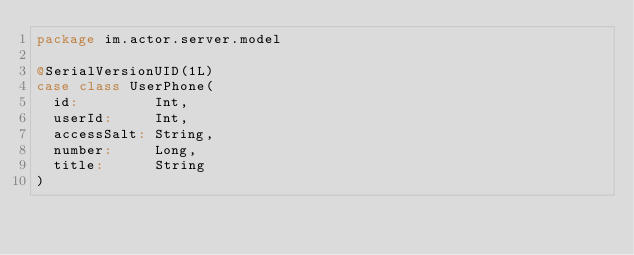Convert code to text. <code><loc_0><loc_0><loc_500><loc_500><_Scala_>package im.actor.server.model

@SerialVersionUID(1L)
case class UserPhone(
  id:         Int,
  userId:     Int,
  accessSalt: String,
  number:     Long,
  title:      String
)
</code> 